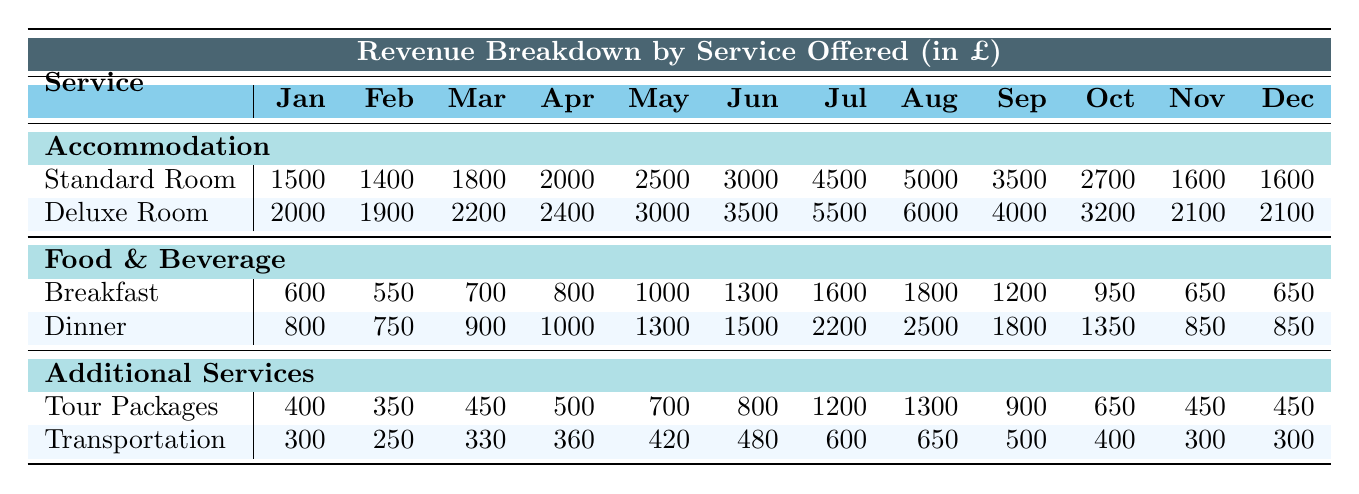What was the revenue from Standard Rooms in July? The table shows that the revenue from Standard Rooms in July is 4500.
Answer: 4500 What is the highest revenue month for Deluxe Rooms? Looking at Deluxe Room revenue, August has the highest value with 6000.
Answer: 6000 Which month had the lowest Breakfast revenue? The lowest Breakfast revenue is in February with 550.
Answer: 550 What is the total revenue from all services in January? Summing the revenues for January: Standard Room (1500) + Deluxe Room (2000) + Breakfast (600) + Dinner (800) + Tour Packages (400) + Transportation (300) = 5100.
Answer: 5100 Which service generated more revenue in July, Food & Beverage or Accommodation? In July, Food & Beverage (Dinner + Breakfast = 2200 + 1600 = 3800) is less than Accommodation (Standard Room + Deluxe Room = 4500 + 5500 = 10000).
Answer: Accommodation What is the average revenue from Transportation for the year? Adding the monthly revenues: (300 + 250 + 330 + 360 + 420 + 480 + 600 + 650 + 500 + 400 + 300 + 300) totals to 4190, and dividing by 12 gives an average of 349.17.
Answer: 349.17 Is the revenue from Tour Packages in March greater than the revenue from Breakfast in March? Tour Packages revenue in March is 450, while Breakfast revenue in March is 700, thus 450 is less than 700.
Answer: No What is the percentage increase in revenue for Deluxe Rooms from May to June? The revenue increased from 3000 in May to 3500 in June, which is a difference of 500. The percentage increase is (500/3000)*100 = 16.67%.
Answer: 16.67% What was the total revenue from Accommodation for the year? Adding the revenues: Standard Room (1500 + 1400 + 1800 + 2000 + 2500 + 3000 + 4500 + 5000 + 3500 + 2700 + 1600 + 1600) plus Deluxe Room (2000 + 1900 + 2200 + 2400 + 3000 + 3500 + 5500 + 6000 + 4000 + 3200 + 2100 + 2100) equals 30300.
Answer: 30300 In which month did Dinner revenue exceed 2000? The Dinner revenue exceeds 2000 in July (2200) and August (2500).
Answer: July and August What is the variance of Breakfast revenue for the year? First, find the average of the Breakfast revenues (sum = 11900), which equals approximately 991.67. Then calculate the individual squared differences from the mean and their average to find the variance, which results in about 9581.67.
Answer: 9581.67 